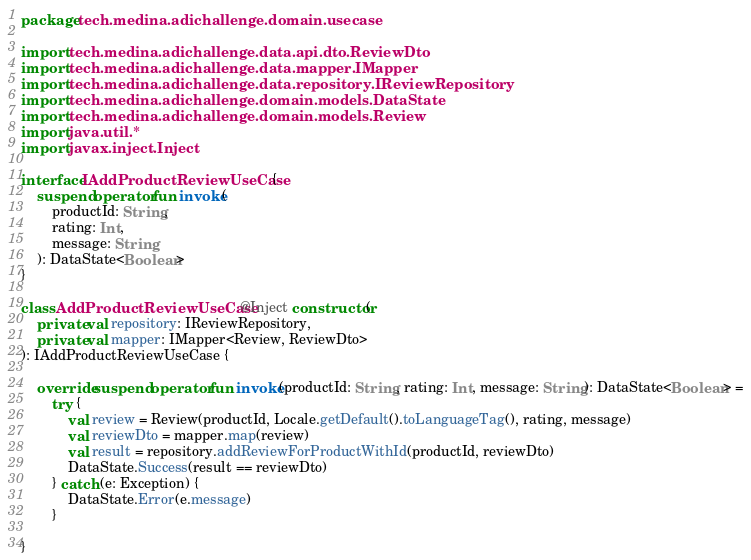Convert code to text. <code><loc_0><loc_0><loc_500><loc_500><_Kotlin_>package tech.medina.adichallenge.domain.usecase

import tech.medina.adichallenge.data.api.dto.ReviewDto
import tech.medina.adichallenge.data.mapper.IMapper
import tech.medina.adichallenge.data.repository.IReviewRepository
import tech.medina.adichallenge.domain.models.DataState
import tech.medina.adichallenge.domain.models.Review
import java.util.*
import javax.inject.Inject

interface IAddProductReviewUseCase {
    suspend operator fun invoke(
        productId: String,
        rating: Int,
        message: String
    ): DataState<Boolean>
}

class AddProductReviewUseCase @Inject constructor(
    private val repository: IReviewRepository,
    private val mapper: IMapper<Review, ReviewDto>
): IAddProductReviewUseCase {

    override suspend operator fun invoke(productId: String, rating: Int, message: String): DataState<Boolean> =
        try {
            val review = Review(productId, Locale.getDefault().toLanguageTag(), rating, message)
            val reviewDto = mapper.map(review)
            val result = repository.addReviewForProductWithId(productId, reviewDto)
            DataState.Success(result == reviewDto)
        } catch (e: Exception) {
            DataState.Error(e.message)
        }

}</code> 